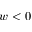<formula> <loc_0><loc_0><loc_500><loc_500>w < 0</formula> 